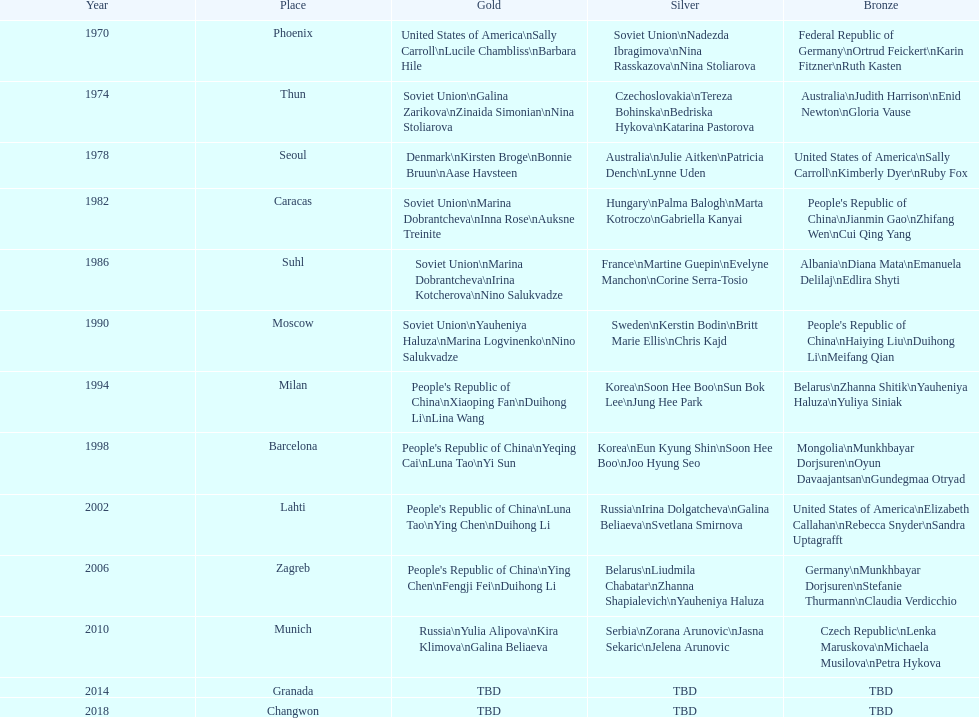What are the total number of times the soviet union is listed under the gold column? 4. 